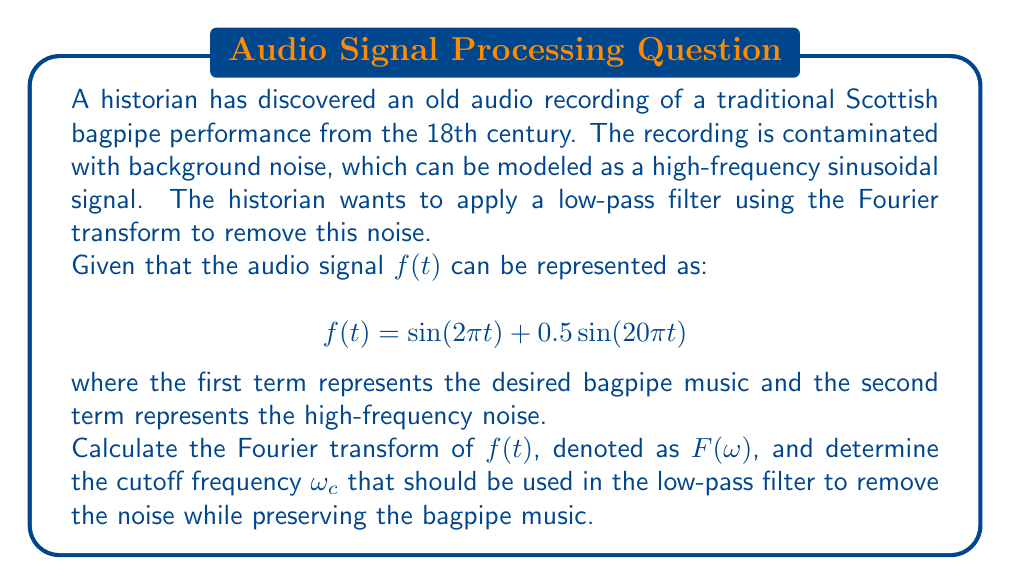Can you answer this question? Let's approach this step-by-step:

1) The Fourier transform of $f(t)$ is given by:

   $$F(\omega) = \int_{-\infty}^{\infty} f(t) e^{-i\omega t} dt$$

2) We need to calculate the Fourier transform of each term separately and then add them:

   $$F(\omega) = \mathcal{F}\{\sin(2\pi t)\} + \mathcal{F}\{0.5\sin(20\pi t)\}$$

3) Recall that the Fourier transform of $\sin(at)$ is:

   $$\mathcal{F}\{\sin(at)\} = \frac{i}{2}[\delta(\omega+a) - \delta(\omega-a)]$$

   where $\delta$ is the Dirac delta function.

4) Applying this to our function:

   $$F(\omega) = \frac{i}{2}[\delta(\omega+2\pi) - \delta(\omega-2\pi)] + \frac{0.5i}{2}[\delta(\omega+20\pi) - \delta(\omega-20\pi)]$$

5) This result shows that the Fourier transform has four impulses:
   - Two at $\omega = \pm 2\pi$ (corresponding to the bagpipe music)
   - Two at $\omega = \pm 20\pi$ (corresponding to the noise)

6) To remove the noise while preserving the bagpipe music, we need to choose a cutoff frequency $\omega_c$ that lies between these two frequencies:

   $$2\pi < \omega_c < 20\pi$$

7) A good choice would be the geometric mean of these frequencies:

   $$\omega_c = \sqrt{2\pi \cdot 20\pi} = \sqrt{40\pi^2} = 2\pi\sqrt{10} \approx 19.87$$
Answer: $\omega_c = 2\pi\sqrt{10}$ 